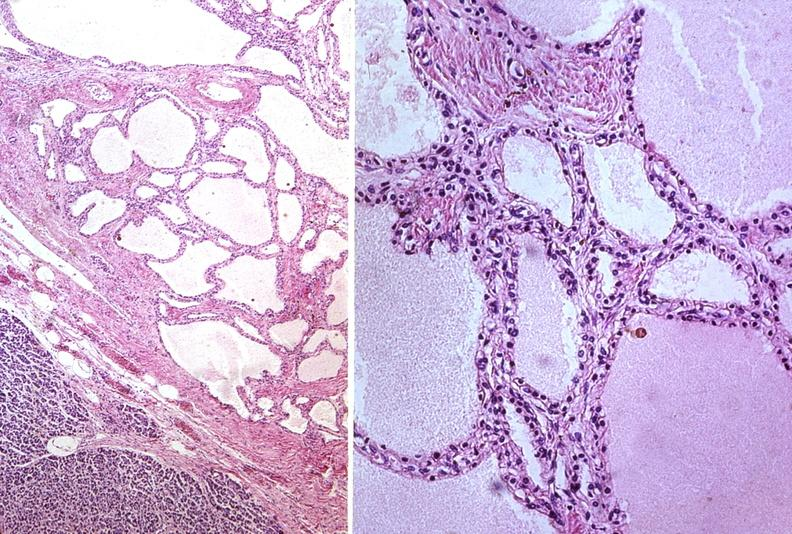does this image show cystadenoma?
Answer the question using a single word or phrase. Yes 